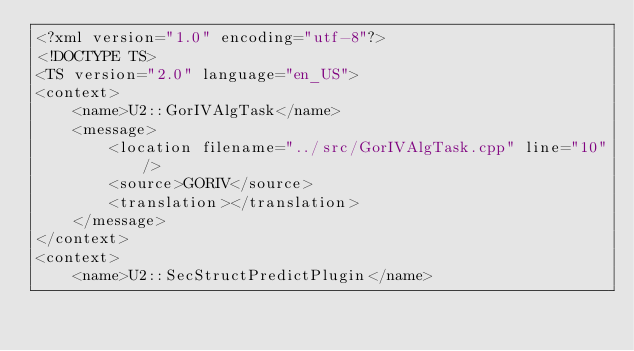<code> <loc_0><loc_0><loc_500><loc_500><_TypeScript_><?xml version="1.0" encoding="utf-8"?>
<!DOCTYPE TS>
<TS version="2.0" language="en_US">
<context>
    <name>U2::GorIVAlgTask</name>
    <message>
        <location filename="../src/GorIVAlgTask.cpp" line="10"/>
        <source>GORIV</source>
        <translation></translation>
    </message>
</context>
<context>
    <name>U2::SecStructPredictPlugin</name></code> 